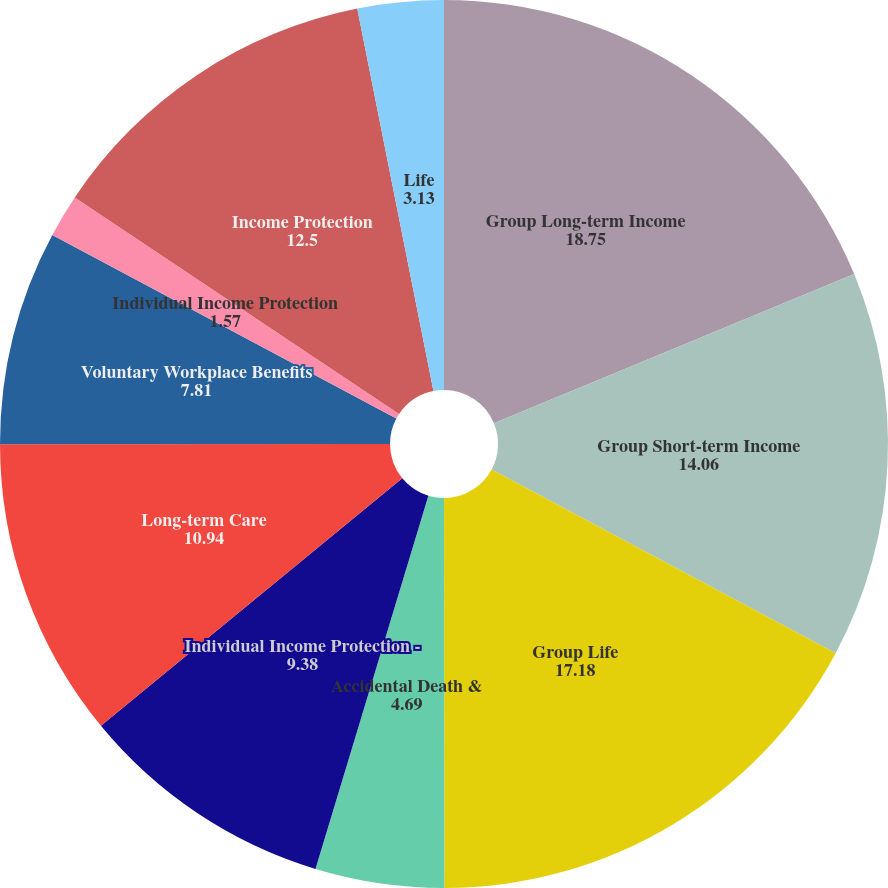Convert chart. <chart><loc_0><loc_0><loc_500><loc_500><pie_chart><fcel>Group Long-term Income<fcel>Group Short-term Income<fcel>Group Life<fcel>Accidental Death &<fcel>Individual Income Protection -<fcel>Long-term Care<fcel>Voluntary Workplace Benefits<fcel>Individual Income Protection<fcel>Income Protection<fcel>Life<nl><fcel>18.75%<fcel>14.06%<fcel>17.18%<fcel>4.69%<fcel>9.38%<fcel>10.94%<fcel>7.81%<fcel>1.57%<fcel>12.5%<fcel>3.13%<nl></chart> 